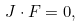Convert formula to latex. <formula><loc_0><loc_0><loc_500><loc_500>J \cdot F = 0 ,</formula> 